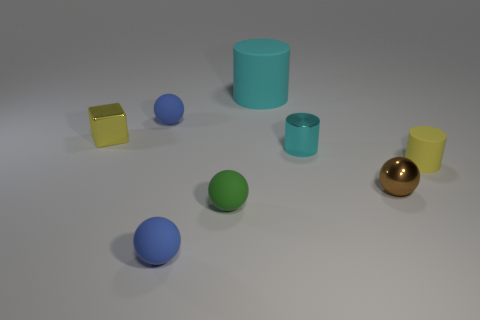Which objects in the image are cylindrical? There are two cylindrical objects in the image: the large one is blue, and the smaller one is teal. 